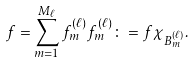Convert formula to latex. <formula><loc_0><loc_0><loc_500><loc_500>f = \sum _ { m = 1 } ^ { M _ { \ell } } f _ { m } ^ { ( \ell ) } f _ { m } ^ { ( \ell ) } \colon = f \chi _ { B _ { m } ^ { ( \ell ) } } .</formula> 